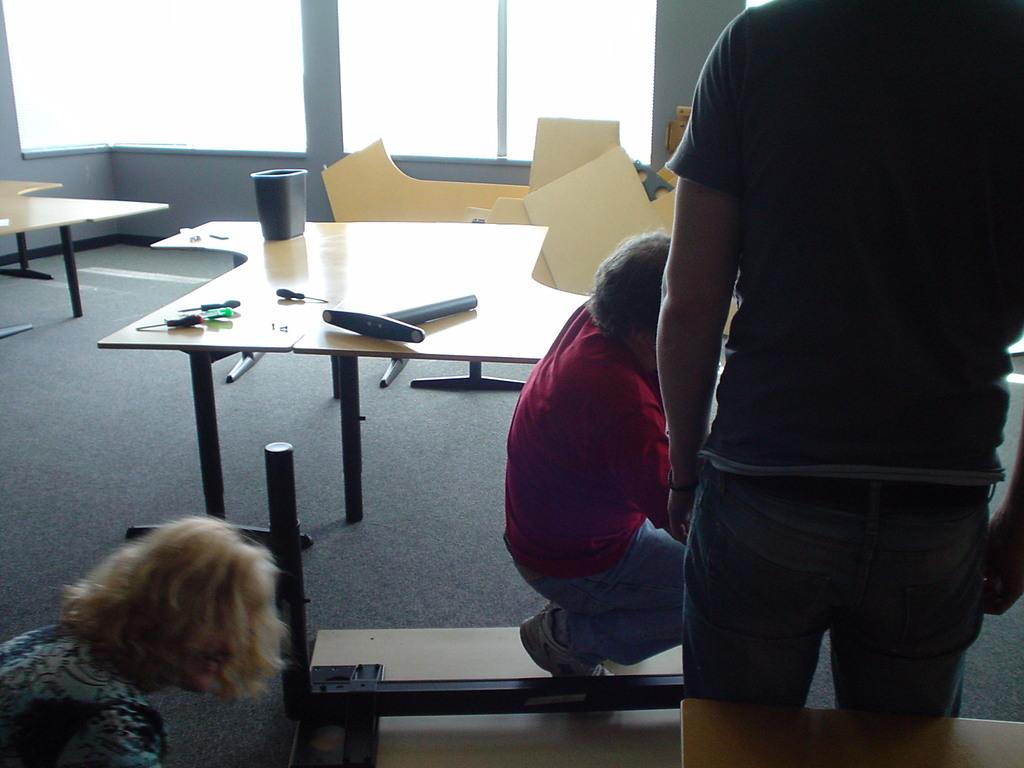How many people are present in the image? There are three people in the image. What can be seen on the table in the image? There are tools on a table in the image. How many frogs are sitting on the table in the image? There are no frogs present in the image; only the three people and tools on the table are visible. 